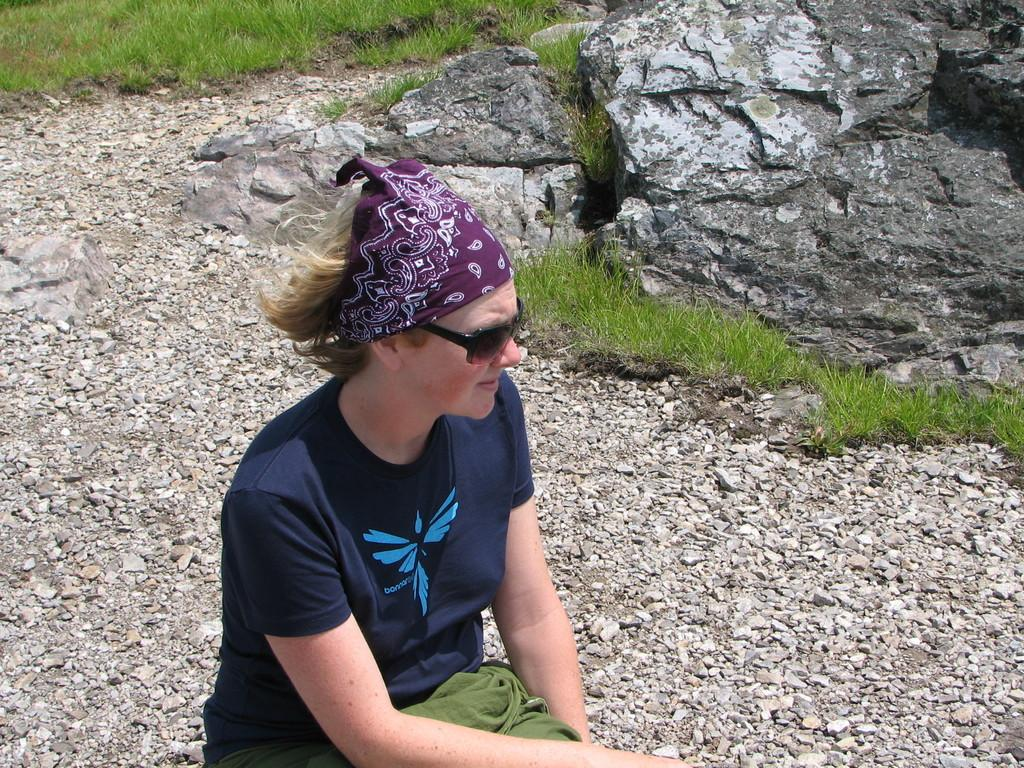What is the person in the image doing? The person is sitting on the surface of the rocks. What type of vegetation can be seen in the image? There is grass visible at the top of the image. What type of wine is the person holding in the image? There is no wine present in the image; the person is simply sitting on the rocks. 